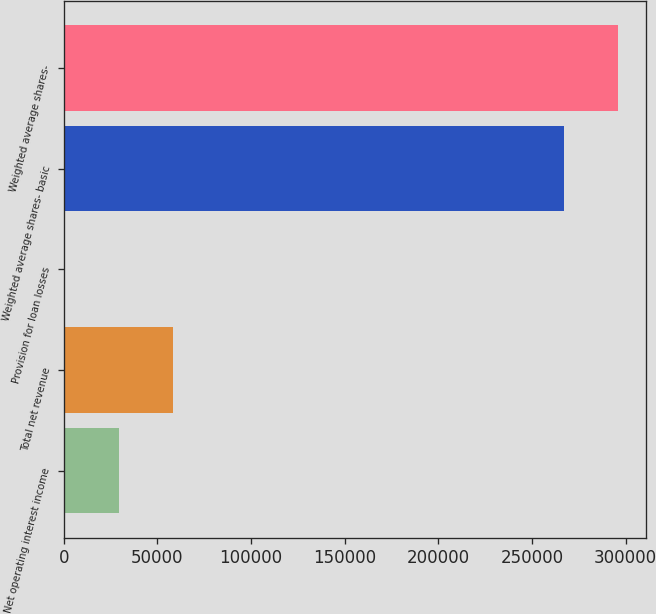<chart> <loc_0><loc_0><loc_500><loc_500><bar_chart><fcel>Net operating interest income<fcel>Total net revenue<fcel>Provision for loan losses<fcel>Weighted average shares- basic<fcel>Weighted average shares-<nl><fcel>29378.7<fcel>58316.9<fcel>440.6<fcel>267291<fcel>296229<nl></chart> 